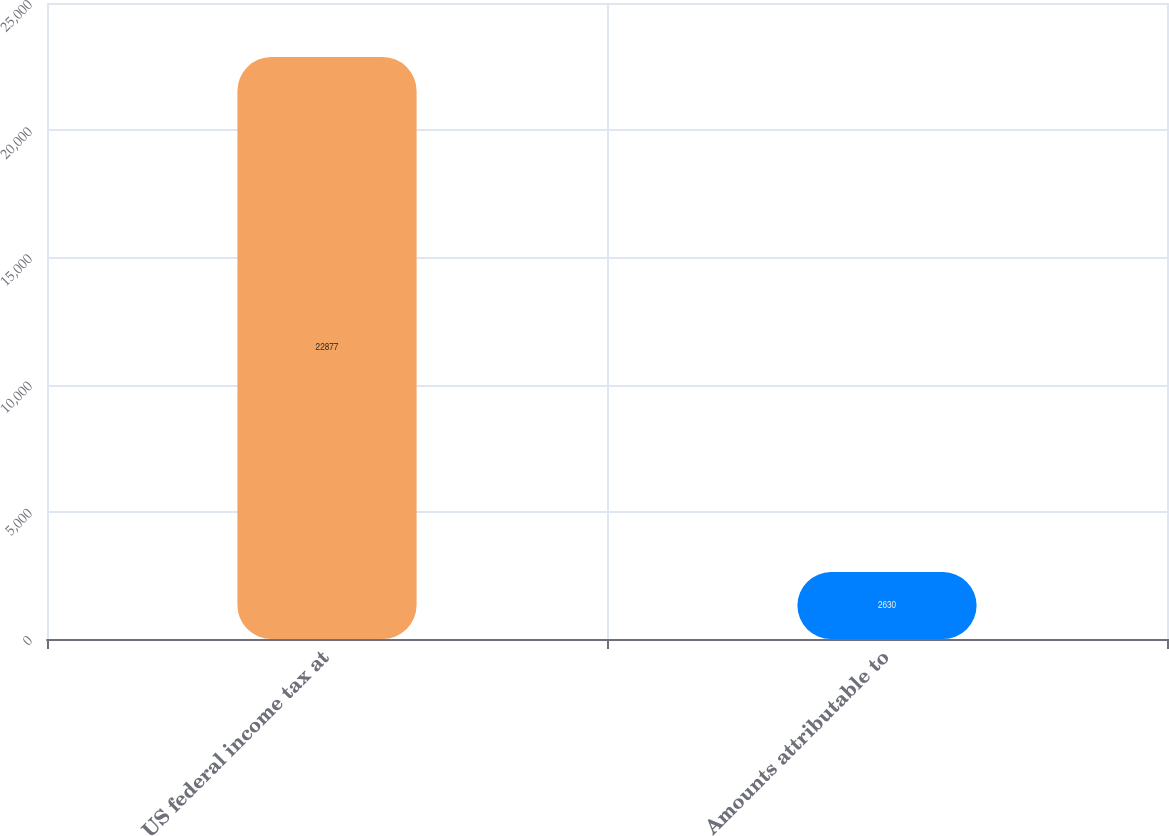<chart> <loc_0><loc_0><loc_500><loc_500><bar_chart><fcel>US federal income tax at<fcel>Amounts attributable to<nl><fcel>22877<fcel>2630<nl></chart> 